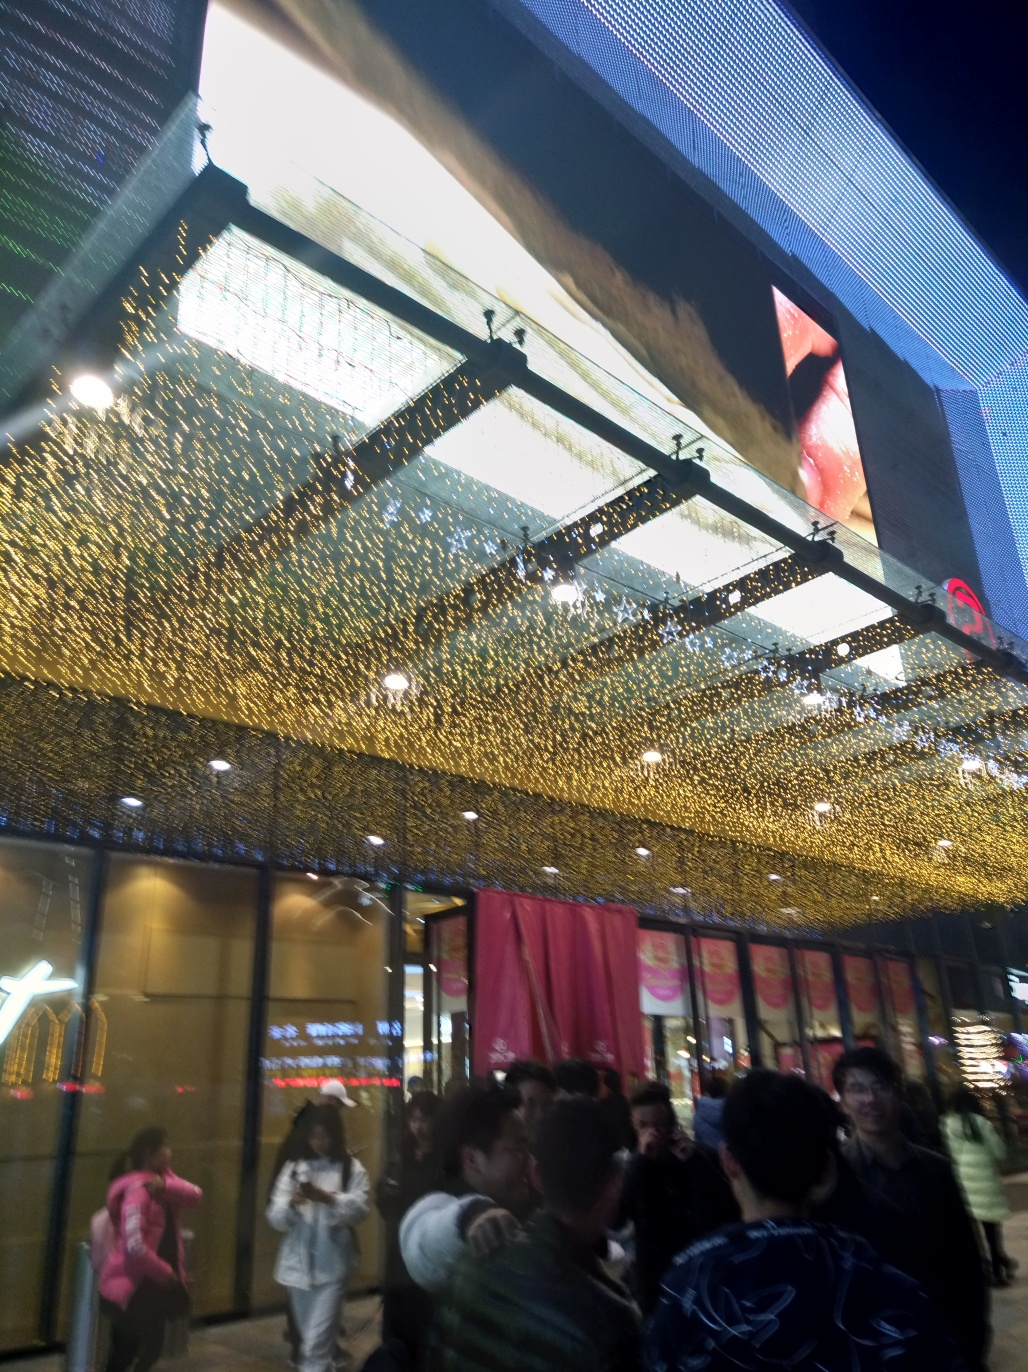What is the main issue regarding the focus of the image? The primary issue concerning the focus of the image is its general blurriness. Details are not sharp throughout, which makes identifying specific features or activities within the scene challenging. Factors contributing to the image's lack of clarity could include motion blur due to camera movement, a low shutter speed, or perhaps an autofocus mistake where the camera didn't properly lock onto a subject before the picture was taken. 